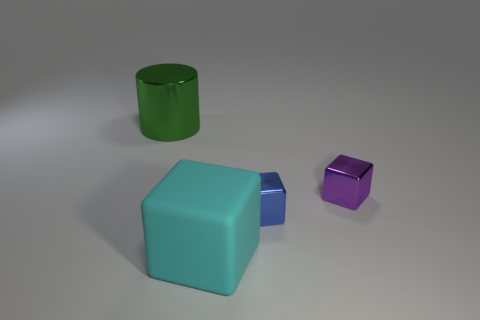What shapes are present in this image? The image features three distinct shapes: a large teal cube, a smaller blue cube, and a green cylindrical object. 